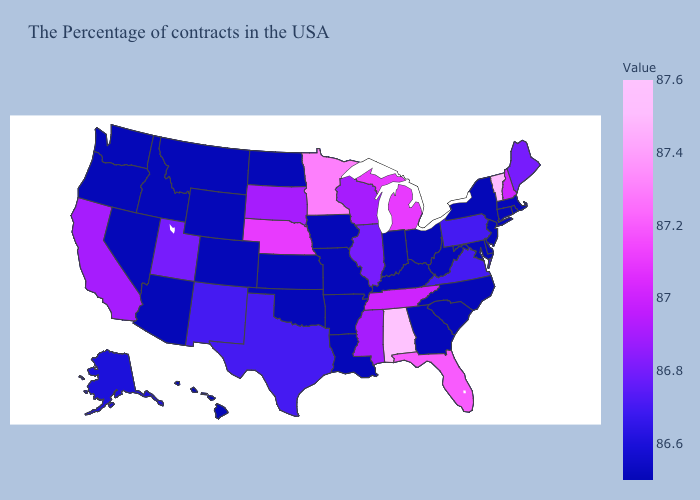Among the states that border Texas , does Oklahoma have the highest value?
Concise answer only. No. Which states have the highest value in the USA?
Write a very short answer. Alabama. Which states have the lowest value in the South?
Keep it brief. Delaware, Maryland, North Carolina, South Carolina, West Virginia, Georgia, Kentucky, Louisiana, Arkansas, Oklahoma. Does Virginia have the highest value in the South?
Concise answer only. No. Among the states that border California , which have the lowest value?
Quick response, please. Arizona, Nevada, Oregon. Among the states that border South Dakota , does Nebraska have the lowest value?
Keep it brief. No. 